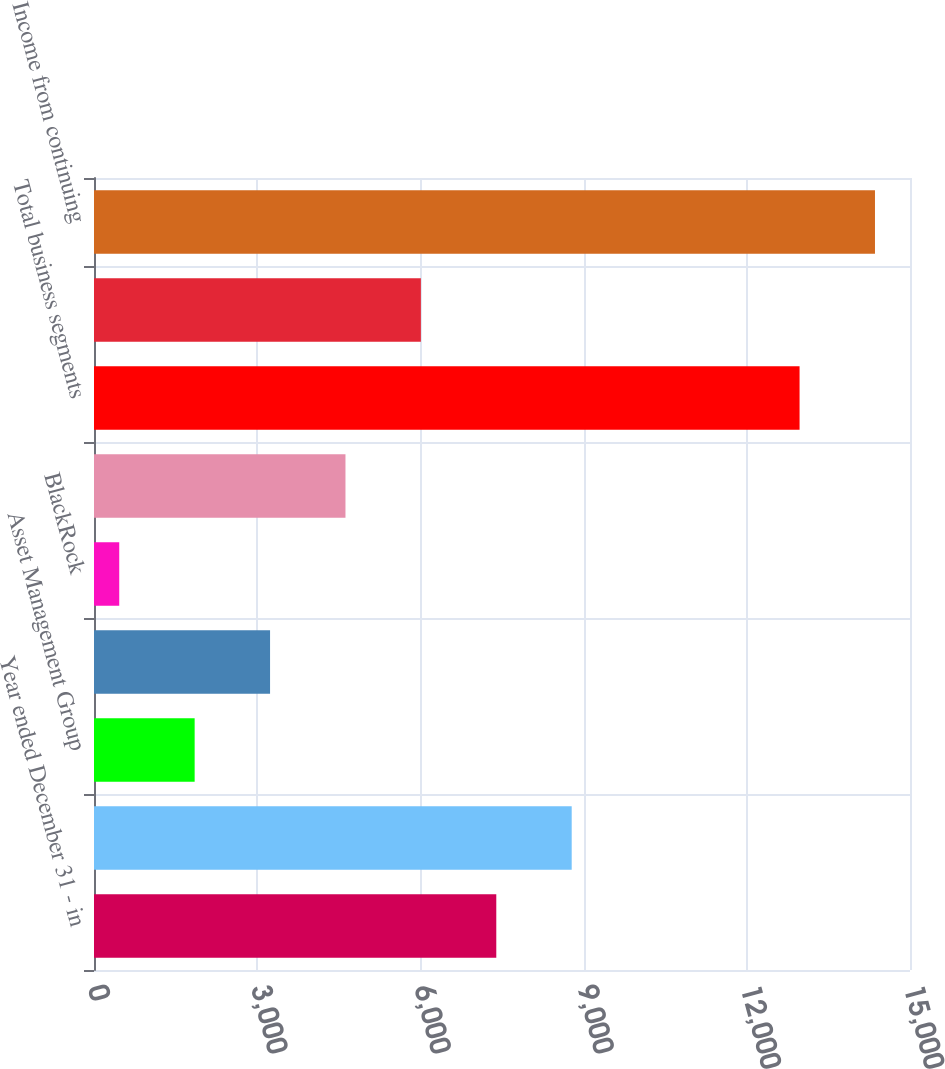Convert chart to OTSL. <chart><loc_0><loc_0><loc_500><loc_500><bar_chart><fcel>Year ended December 31 - in<fcel>Corporate & Institutional<fcel>Asset Management Group<fcel>Residential Mortgage Banking<fcel>BlackRock<fcel>Non-Strategic Assets Portfolio<fcel>Total business segments<fcel>Other (b) (c)<fcel>Income from continuing<nl><fcel>7395<fcel>8781.2<fcel>1850.2<fcel>3236.4<fcel>464<fcel>4622.6<fcel>12970<fcel>6008.8<fcel>14356.2<nl></chart> 